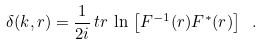Convert formula to latex. <formula><loc_0><loc_0><loc_500><loc_500>\delta ( k , r ) = \frac { 1 } { 2 i } \, t r \, \ln \, \left [ F ^ { - 1 } ( r ) F ^ { * } ( r ) \right ] \ .</formula> 